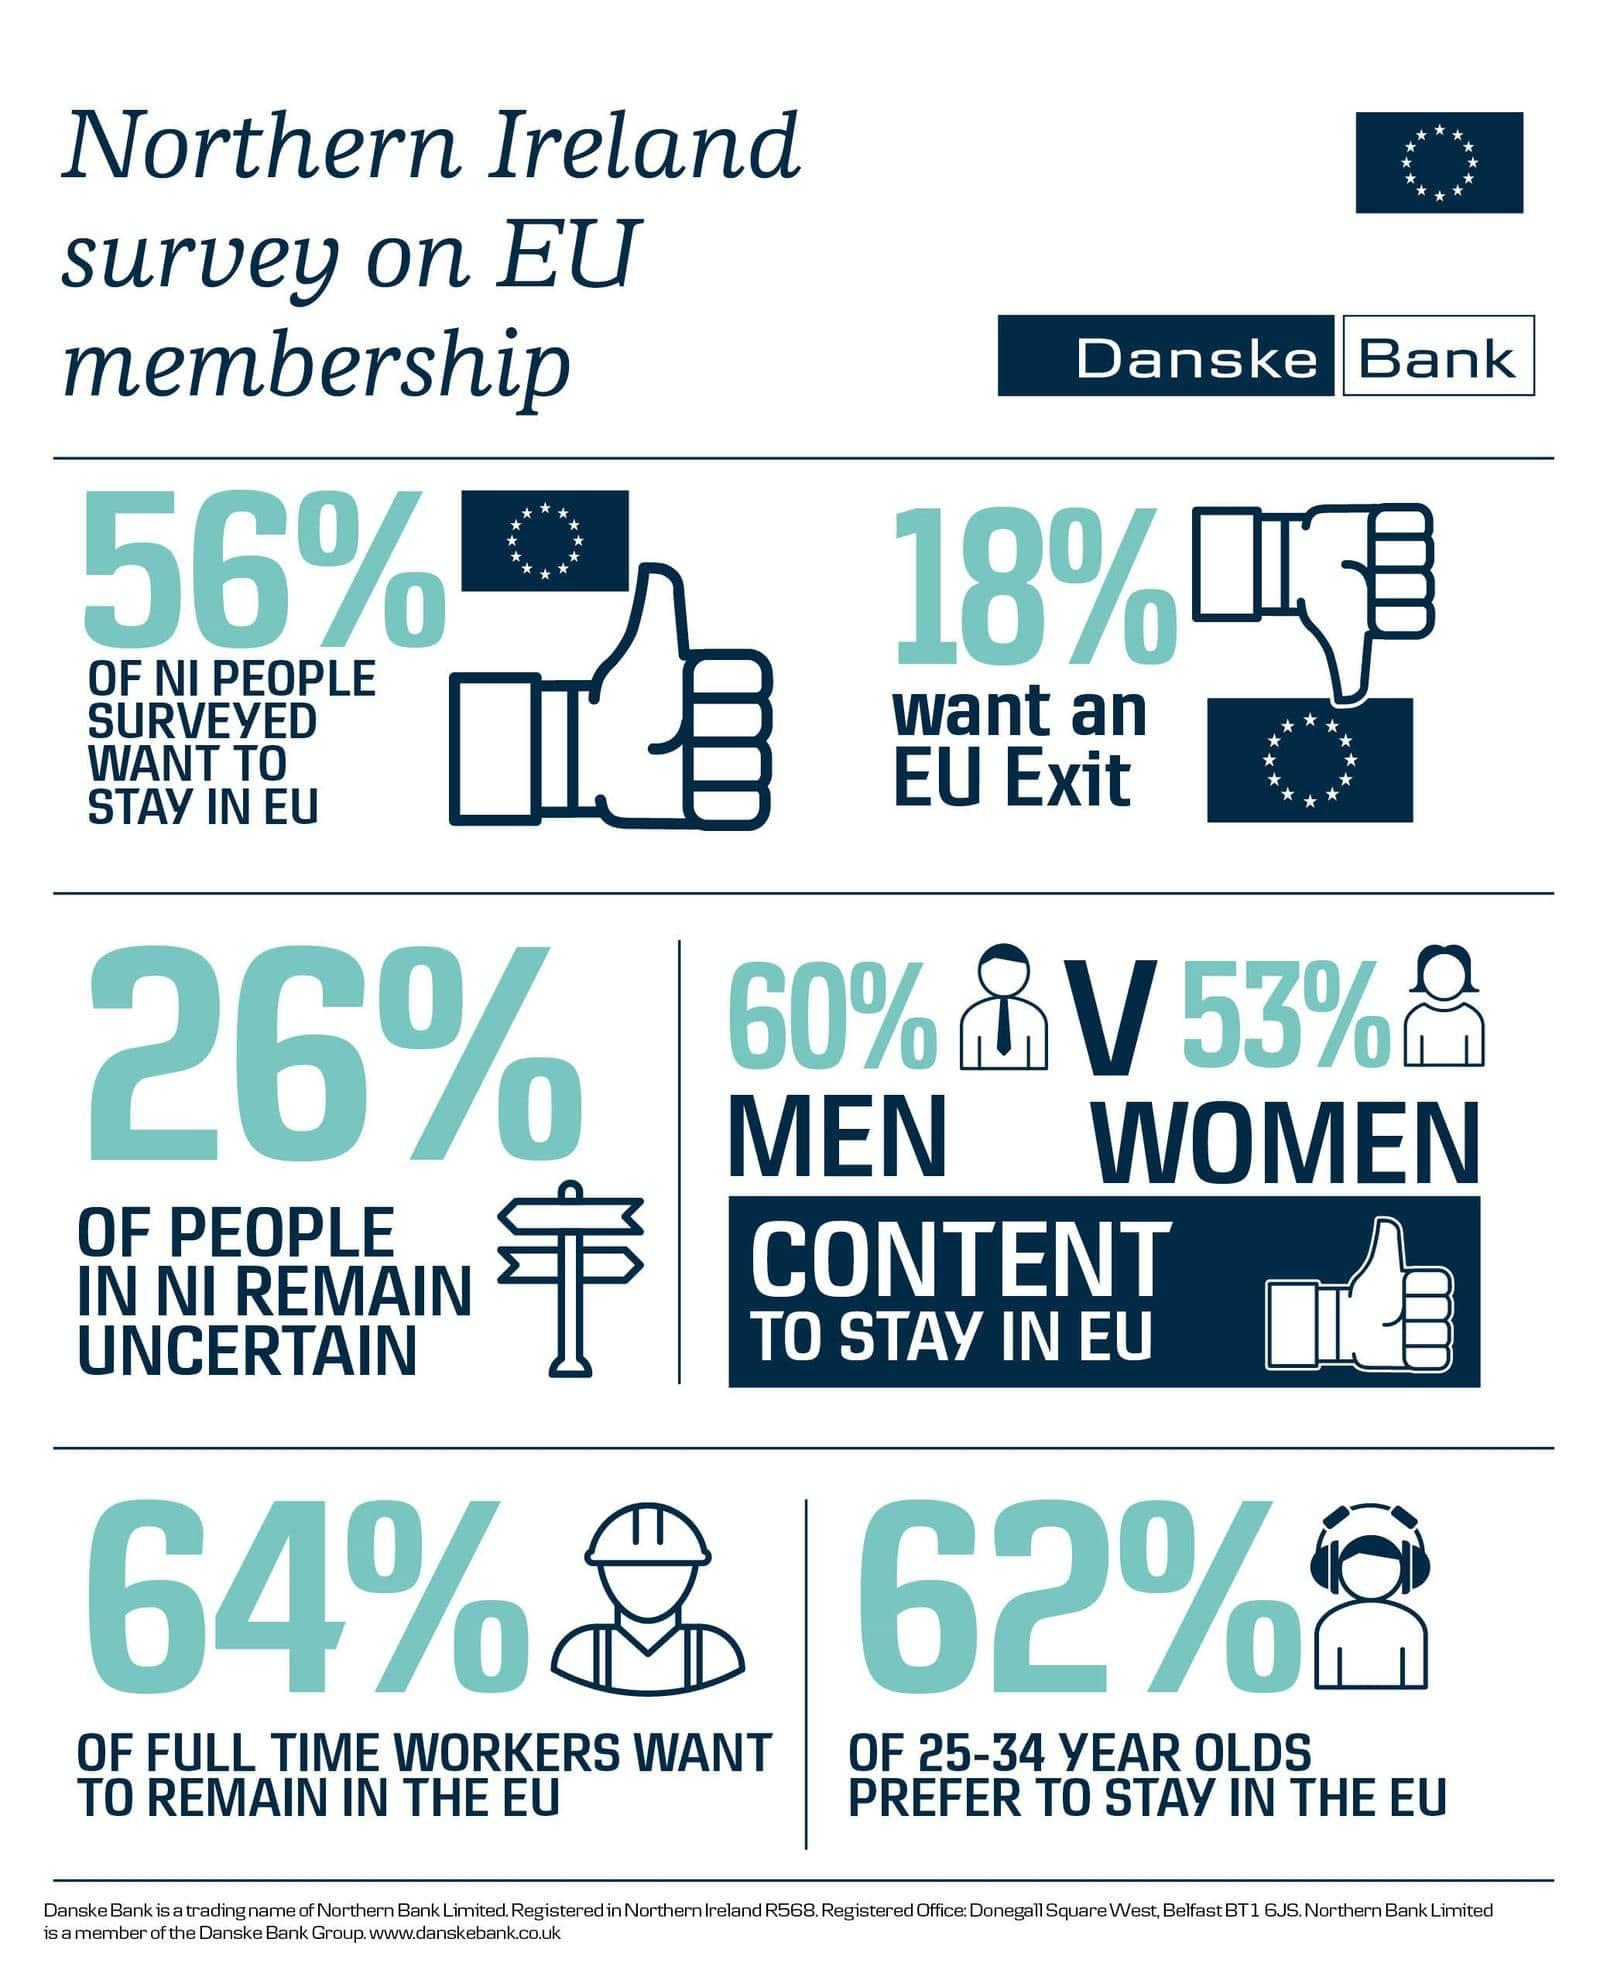Point out several critical features in this image. In Northern Ireland, 26% of people still remain uncertain about a particular topic. According to a recent survey, 64% of full-time workers in Northern Ireland wish to remain in the EU. According to a survey, 62% of people aged 25-34 years in Northern Ireland prefer to stay in the EU. A survey of people in Northern Ireland shows that 18% want to leave the EU. 